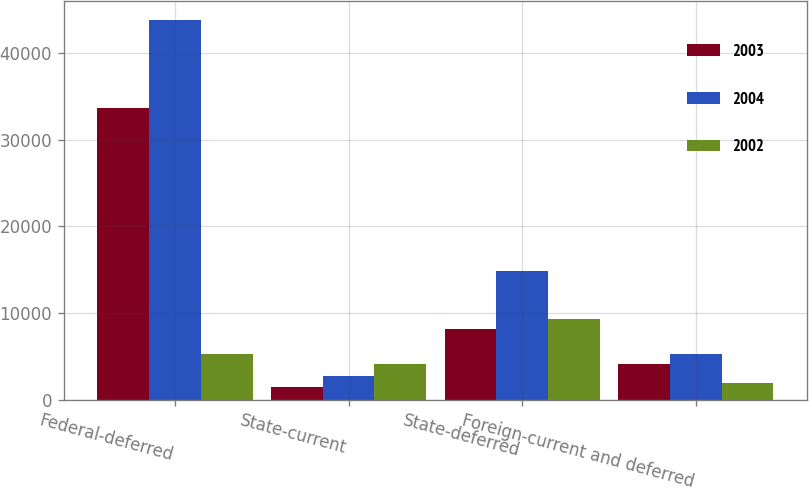Convert chart. <chart><loc_0><loc_0><loc_500><loc_500><stacked_bar_chart><ecel><fcel>Federal-deferred<fcel>State-current<fcel>State-deferred<fcel>Foreign-current and deferred<nl><fcel>2003<fcel>33629<fcel>1447<fcel>8121<fcel>4121<nl><fcel>2004<fcel>43856<fcel>2758<fcel>14871<fcel>5245<nl><fcel>2002<fcel>5245<fcel>4094<fcel>9339<fcel>1904<nl></chart> 